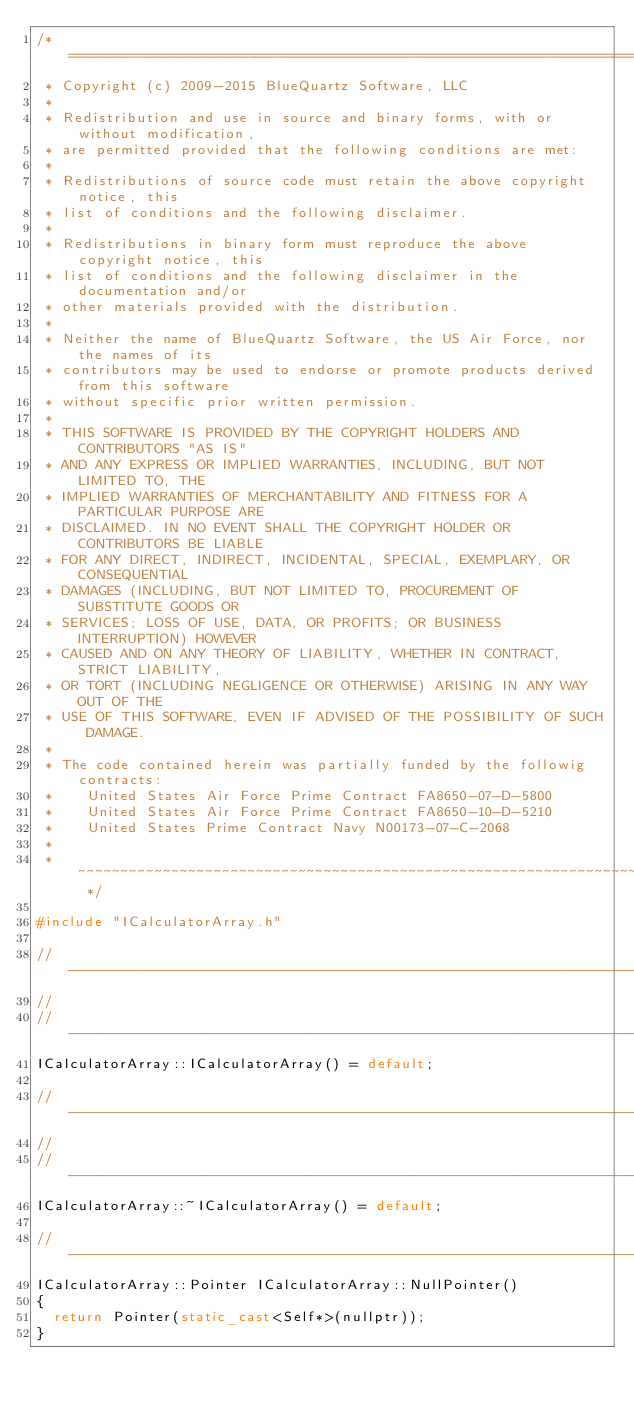<code> <loc_0><loc_0><loc_500><loc_500><_C++_>/* ============================================================================
 * Copyright (c) 2009-2015 BlueQuartz Software, LLC
 *
 * Redistribution and use in source and binary forms, with or without modification,
 * are permitted provided that the following conditions are met:
 *
 * Redistributions of source code must retain the above copyright notice, this
 * list of conditions and the following disclaimer.
 *
 * Redistributions in binary form must reproduce the above copyright notice, this
 * list of conditions and the following disclaimer in the documentation and/or
 * other materials provided with the distribution.
 *
 * Neither the name of BlueQuartz Software, the US Air Force, nor the names of its
 * contributors may be used to endorse or promote products derived from this software
 * without specific prior written permission.
 *
 * THIS SOFTWARE IS PROVIDED BY THE COPYRIGHT HOLDERS AND CONTRIBUTORS "AS IS"
 * AND ANY EXPRESS OR IMPLIED WARRANTIES, INCLUDING, BUT NOT LIMITED TO, THE
 * IMPLIED WARRANTIES OF MERCHANTABILITY AND FITNESS FOR A PARTICULAR PURPOSE ARE
 * DISCLAIMED. IN NO EVENT SHALL THE COPYRIGHT HOLDER OR CONTRIBUTORS BE LIABLE
 * FOR ANY DIRECT, INDIRECT, INCIDENTAL, SPECIAL, EXEMPLARY, OR CONSEQUENTIAL
 * DAMAGES (INCLUDING, BUT NOT LIMITED TO, PROCUREMENT OF SUBSTITUTE GOODS OR
 * SERVICES; LOSS OF USE, DATA, OR PROFITS; OR BUSINESS INTERRUPTION) HOWEVER
 * CAUSED AND ON ANY THEORY OF LIABILITY, WHETHER IN CONTRACT, STRICT LIABILITY,
 * OR TORT (INCLUDING NEGLIGENCE OR OTHERWISE) ARISING IN ANY WAY OUT OF THE
 * USE OF THIS SOFTWARE, EVEN IF ADVISED OF THE POSSIBILITY OF SUCH DAMAGE.
 *
 * The code contained herein was partially funded by the followig contracts:
 *    United States Air Force Prime Contract FA8650-07-D-5800
 *    United States Air Force Prime Contract FA8650-10-D-5210
 *    United States Prime Contract Navy N00173-07-C-2068
 *
 * ~~~~~~~~~~~~~~~~~~~~~~~~~~~~~~~~~~~~~~~~~~~~~~~~~~~~~~~~~~~~~~~~~~~~~~~~~~ */

#include "ICalculatorArray.h"

// -----------------------------------------------------------------------------
//
// -----------------------------------------------------------------------------
ICalculatorArray::ICalculatorArray() = default;

// -----------------------------------------------------------------------------
//
// -----------------------------------------------------------------------------
ICalculatorArray::~ICalculatorArray() = default;

// -----------------------------------------------------------------------------
ICalculatorArray::Pointer ICalculatorArray::NullPointer()
{
  return Pointer(static_cast<Self*>(nullptr));
}
</code> 